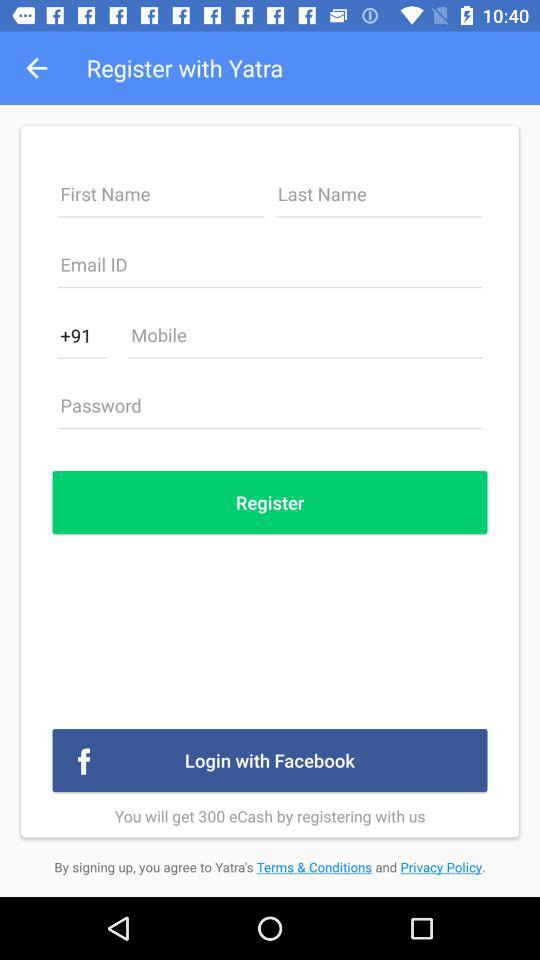What is the code to dial a phone number? The code is +91. 